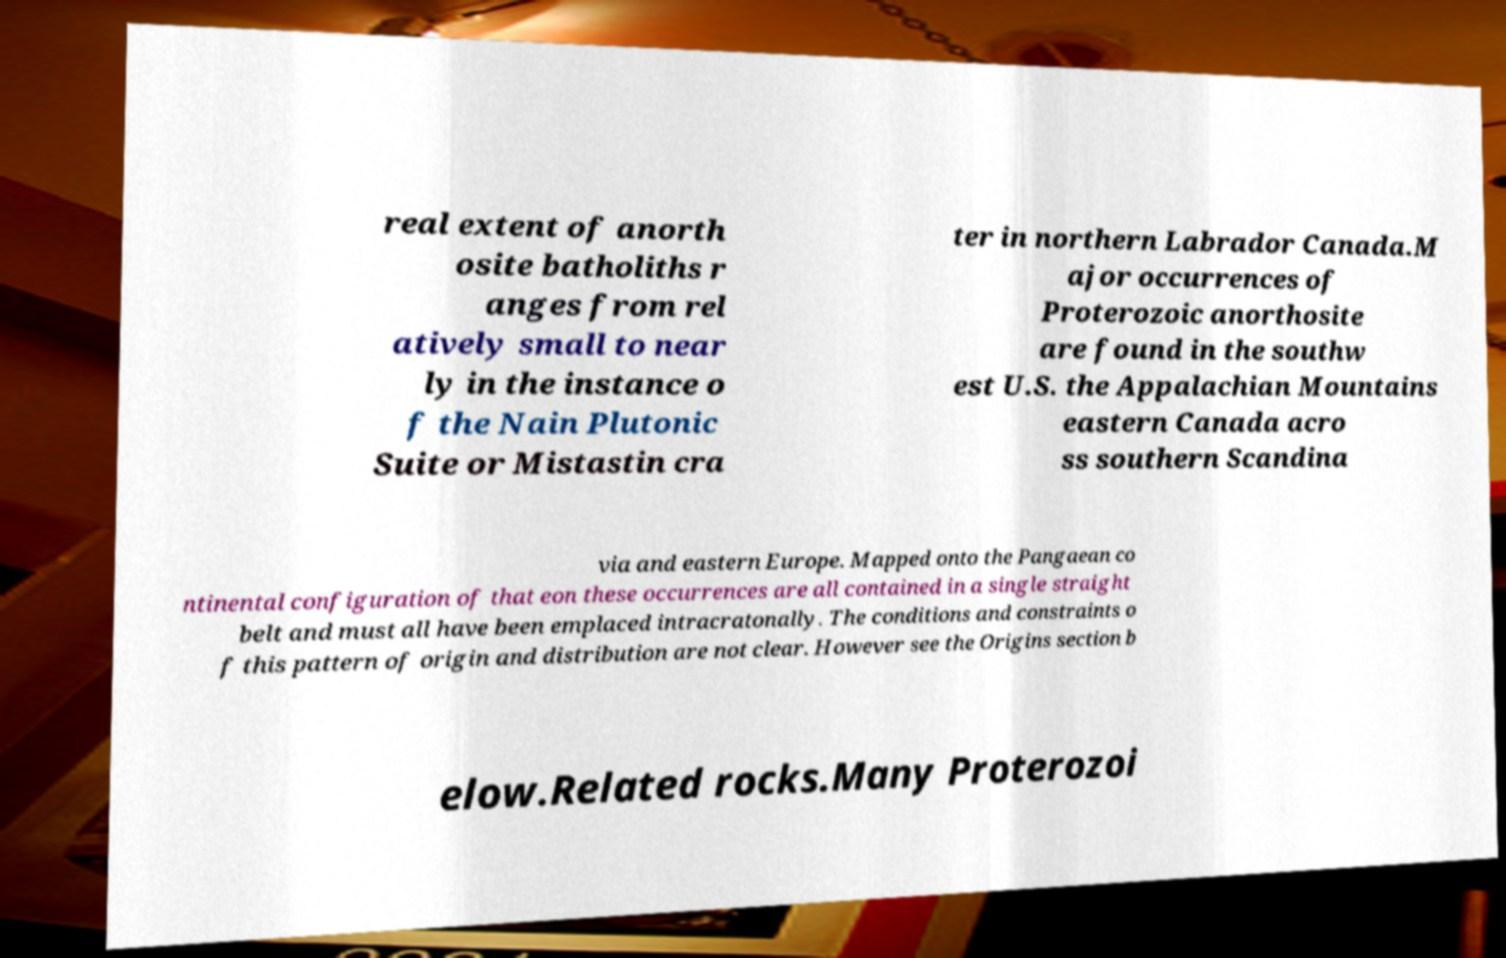I need the written content from this picture converted into text. Can you do that? real extent of anorth osite batholiths r anges from rel atively small to near ly in the instance o f the Nain Plutonic Suite or Mistastin cra ter in northern Labrador Canada.M ajor occurrences of Proterozoic anorthosite are found in the southw est U.S. the Appalachian Mountains eastern Canada acro ss southern Scandina via and eastern Europe. Mapped onto the Pangaean co ntinental configuration of that eon these occurrences are all contained in a single straight belt and must all have been emplaced intracratonally. The conditions and constraints o f this pattern of origin and distribution are not clear. However see the Origins section b elow.Related rocks.Many Proterozoi 